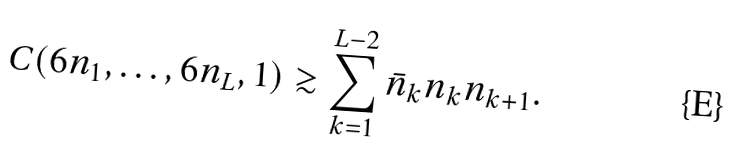Convert formula to latex. <formula><loc_0><loc_0><loc_500><loc_500>C ( 6 n _ { 1 } , \dots , 6 n _ { L } , 1 ) \gtrsim \sum _ { k = 1 } ^ { L - 2 } \bar { n } _ { k } n _ { k } n _ { k + 1 } .</formula> 